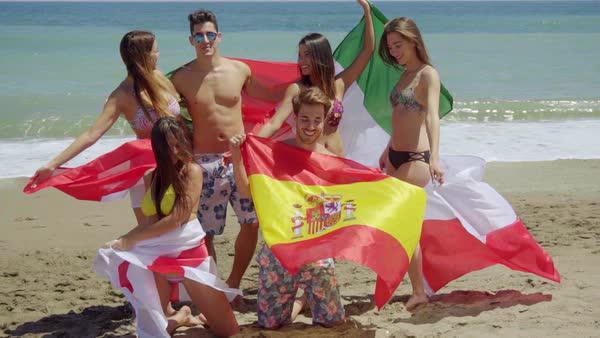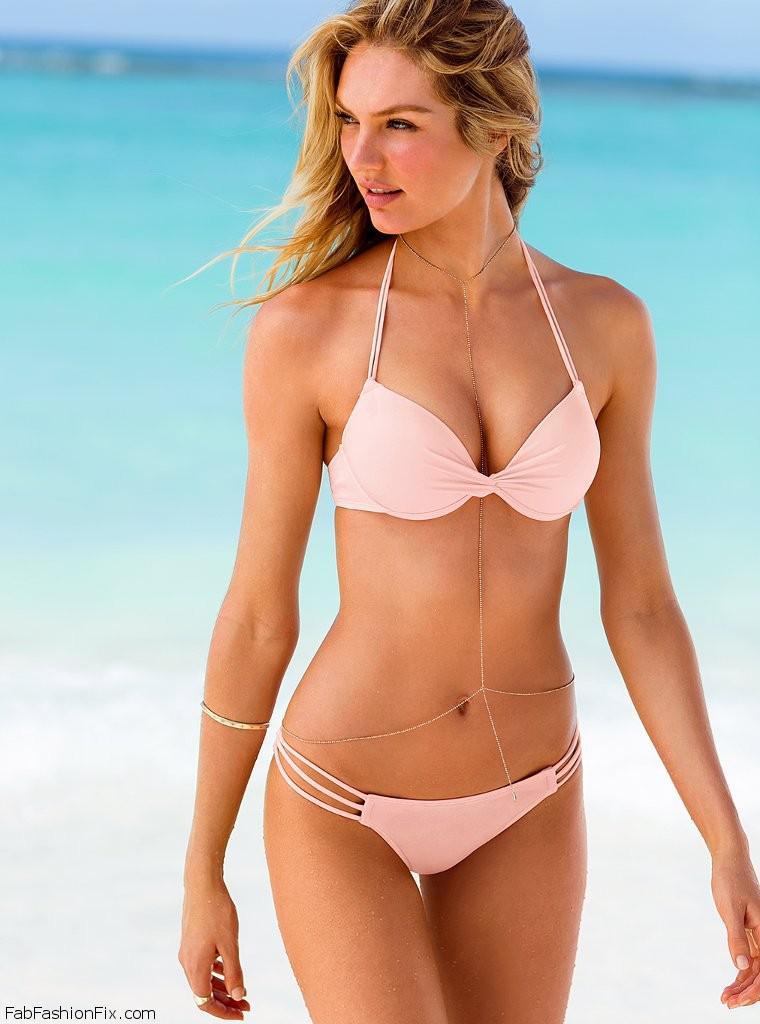The first image is the image on the left, the second image is the image on the right. Analyze the images presented: Is the assertion "Three girls pose together for the picture wearing bikinis." valid? Answer yes or no. No. The first image is the image on the left, the second image is the image on the right. For the images displayed, is the sentence "There are six women wearing swimsuits." factually correct? Answer yes or no. No. 